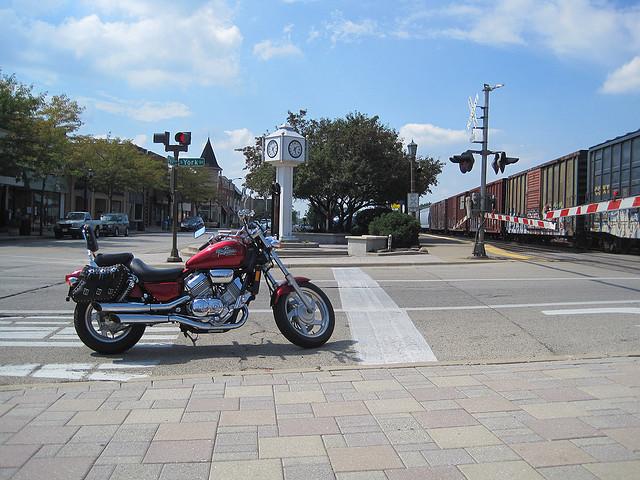What time does the clock say?
Keep it brief. 5:10. Why are the gates down?
Give a very brief answer. Train crossing. How many people can safely ride this motorcycle?
Short answer required. 2. 